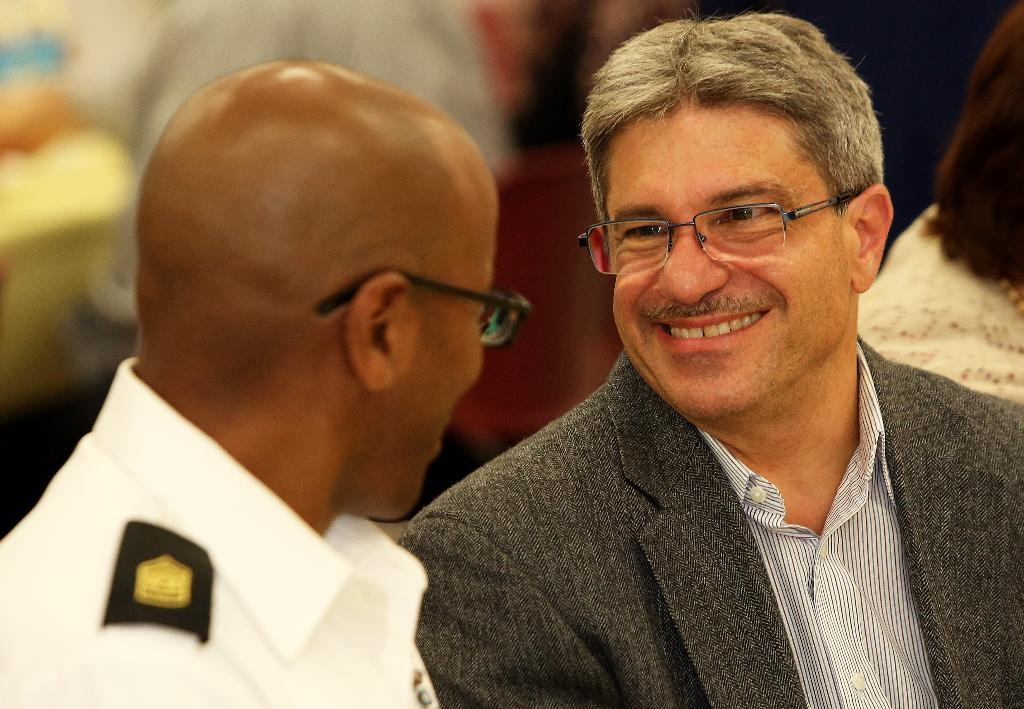How many people are present in the image? There are two people in the image. What is the facial expression of the people in the image? Both people have a smile on their face. Are there any other people visible in the image? Yes, there are a few other people around them. How long does it take for the mountain to appear in the image? There is no mountain present in the image, so it cannot determine how long it would take for it to appear. 